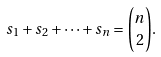<formula> <loc_0><loc_0><loc_500><loc_500>s _ { 1 } + s _ { 2 } + \cdots + s _ { n } = { \binom { n } { 2 } } .</formula> 